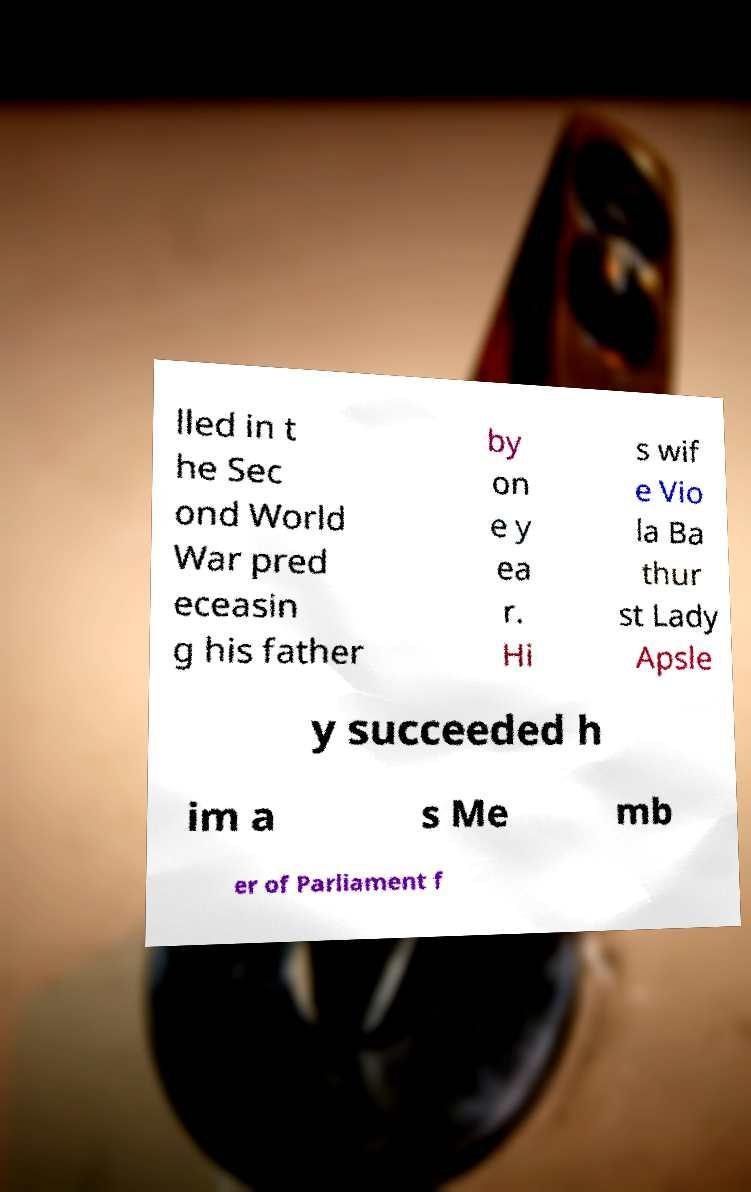Please identify and transcribe the text found in this image. lled in t he Sec ond World War pred eceasin g his father by on e y ea r. Hi s wif e Vio la Ba thur st Lady Apsle y succeeded h im a s Me mb er of Parliament f 